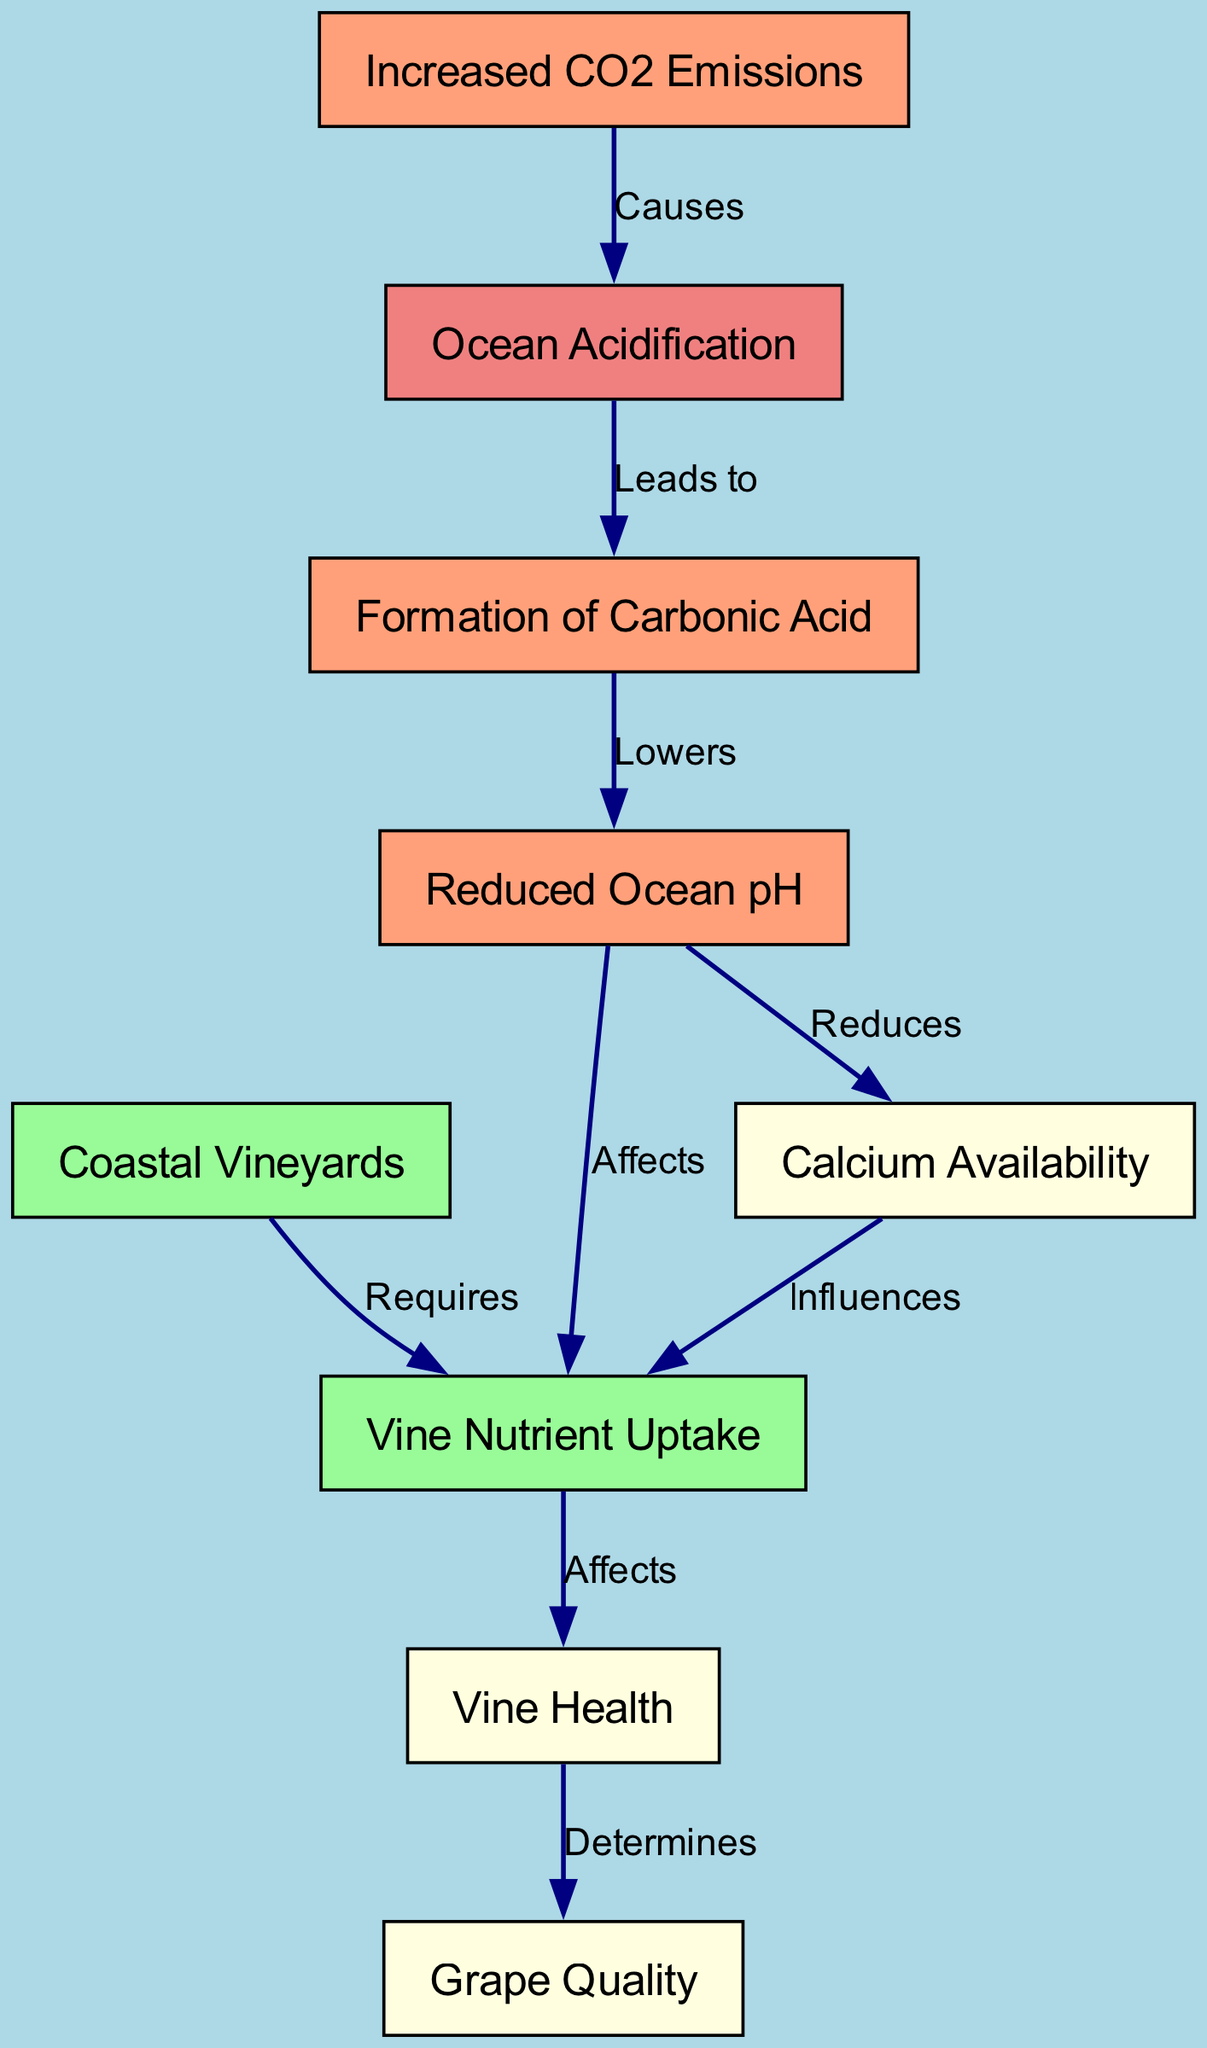What is the foundational cause of ocean acidification in this diagram? The diagram shows that "Increased CO2 Emissions" is annotated with "Causes" pointing to "Ocean Acidification". Thus, it establishes that increased CO2 emissions are the foundational cause.
Answer: Increased CO2 Emissions What node is directly influenced by reduced ocean pH? According to the diagram, the edge originating from "Reduced Ocean pH" points to "Calcium Availability", indicating that calcium availability is directly influenced.
Answer: Calcium Availability How many total nodes are represented in the diagram? Upon inspecting the diagram, there are ten unique nodes listed: Ocean Acidification, Increased CO2 Emissions, Formation of Carbonic Acid, Reduced Ocean pH, Coastal Vineyards, Vine Nutrient Uptake, Calcium Availability, Vine Health, and Grape Quality. This gives a total of nine nodes.
Answer: 9 What relationship exists between vine health and grape quality? The diagram shows that "Vine Health" has an arrow labeled "Determines" pointing to "Grape Quality", indicating that the health of the vines directly determines the quality of the grapes.
Answer: Determines How does ocean acidification influence vine nutrient uptake? Following the flow in the diagram: "Ocean Acidification" leads to "Formation of Carbonic Acid", which then lowers pH ("Reduced Ocean pH"). The reduced pH affects "Nutrient Uptake". Therefore, ocean acidification indirectly decreases vine nutrient uptake through these steps.
Answer: Affects What nutrient availability is impacted by reduced ocean pH? The diagram indicates that "Reduced Ocean pH" has a direct effect labeled "Reduces" on "Calcium Availability", showing that calcium availability is the nutrient affected by reduced pH.
Answer: Calcium Availability Which node requires nutrient uptake according to the diagram? The edge from "Coastal Vineyards" points towards "Nutrient Uptake" with the label "Requires", indicating that coastal vineyards require nutrient uptake to thrive.
Answer: Requires Which node is affected by vine nutrient uptake? The diagram illustrates that "Nutrient Uptake" points to "Vine Health" with the label "Affects". This means that vine health is the node directly affected by nutrient uptake.
Answer: Vine Health 